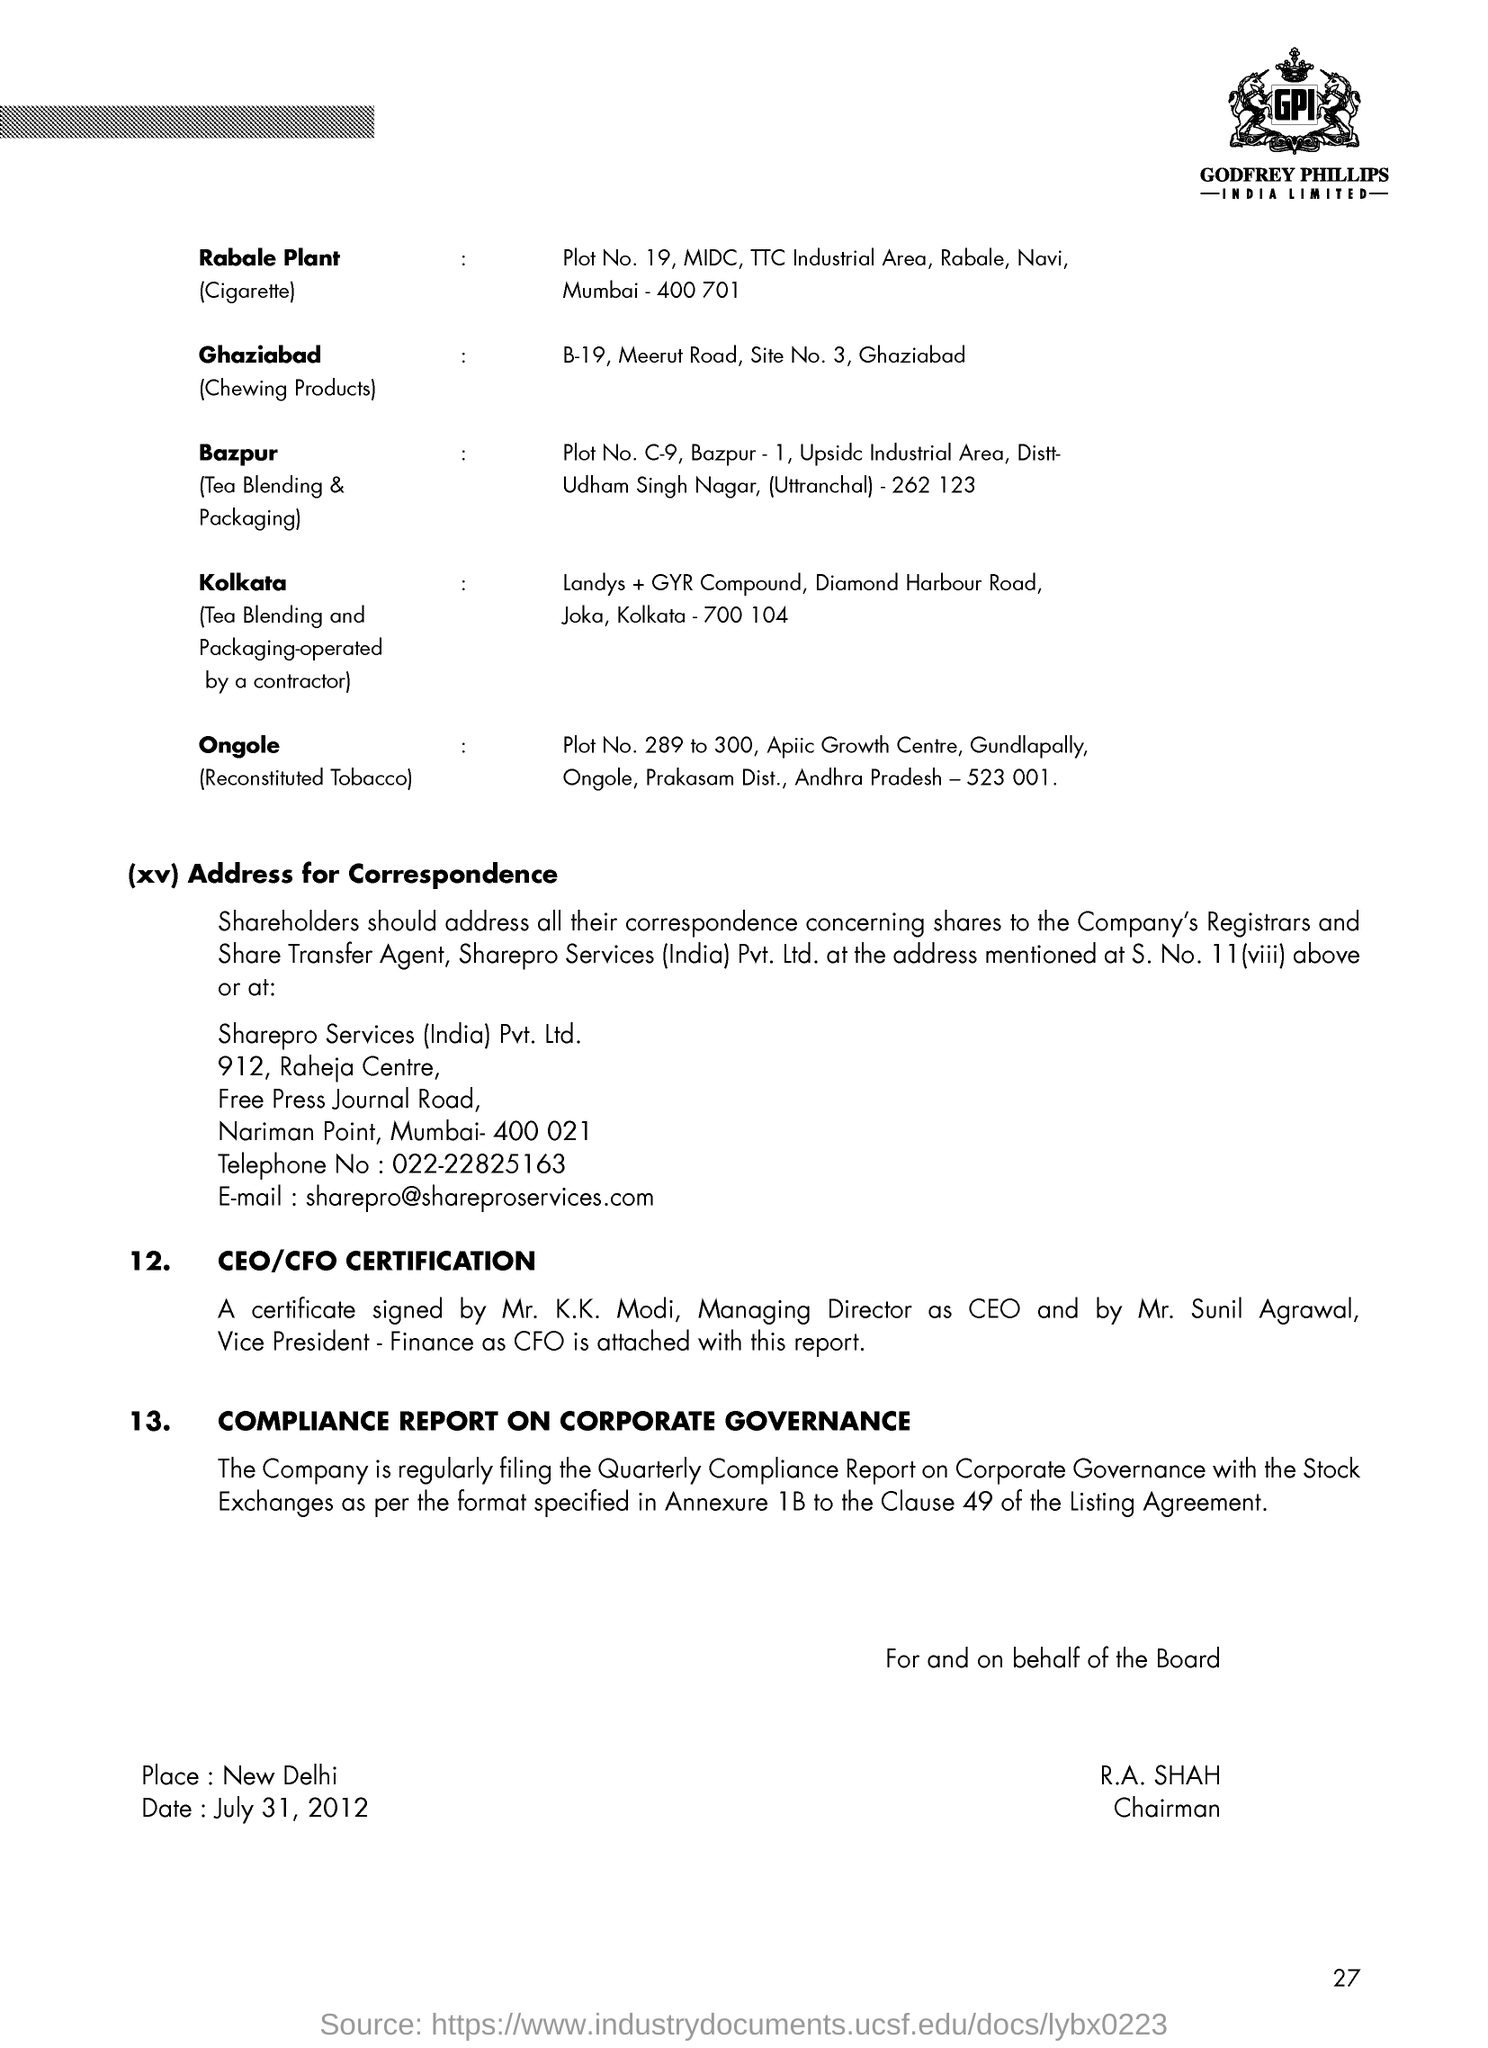Who is the Chairman?
Offer a very short reply. R.A. Shah. What is the date mentioned in the document?
Your response must be concise. July 31, 2012. What is the telephone number?
Offer a very short reply. 022-22825163. What is the Email id?
Make the answer very short. Sharepro@shareproservices.com. What is the Page Number?
Keep it short and to the point. 27. 